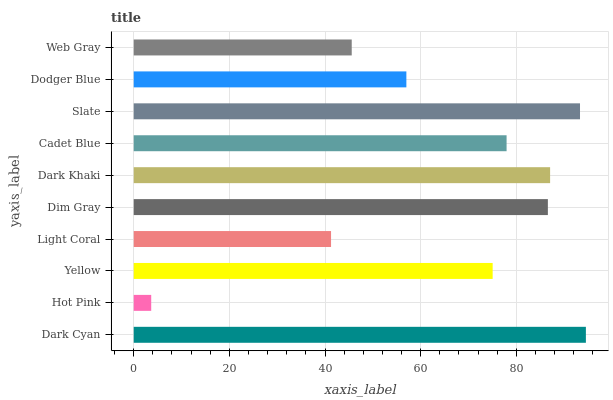Is Hot Pink the minimum?
Answer yes or no. Yes. Is Dark Cyan the maximum?
Answer yes or no. Yes. Is Yellow the minimum?
Answer yes or no. No. Is Yellow the maximum?
Answer yes or no. No. Is Yellow greater than Hot Pink?
Answer yes or no. Yes. Is Hot Pink less than Yellow?
Answer yes or no. Yes. Is Hot Pink greater than Yellow?
Answer yes or no. No. Is Yellow less than Hot Pink?
Answer yes or no. No. Is Cadet Blue the high median?
Answer yes or no. Yes. Is Yellow the low median?
Answer yes or no. Yes. Is Dodger Blue the high median?
Answer yes or no. No. Is Dodger Blue the low median?
Answer yes or no. No. 